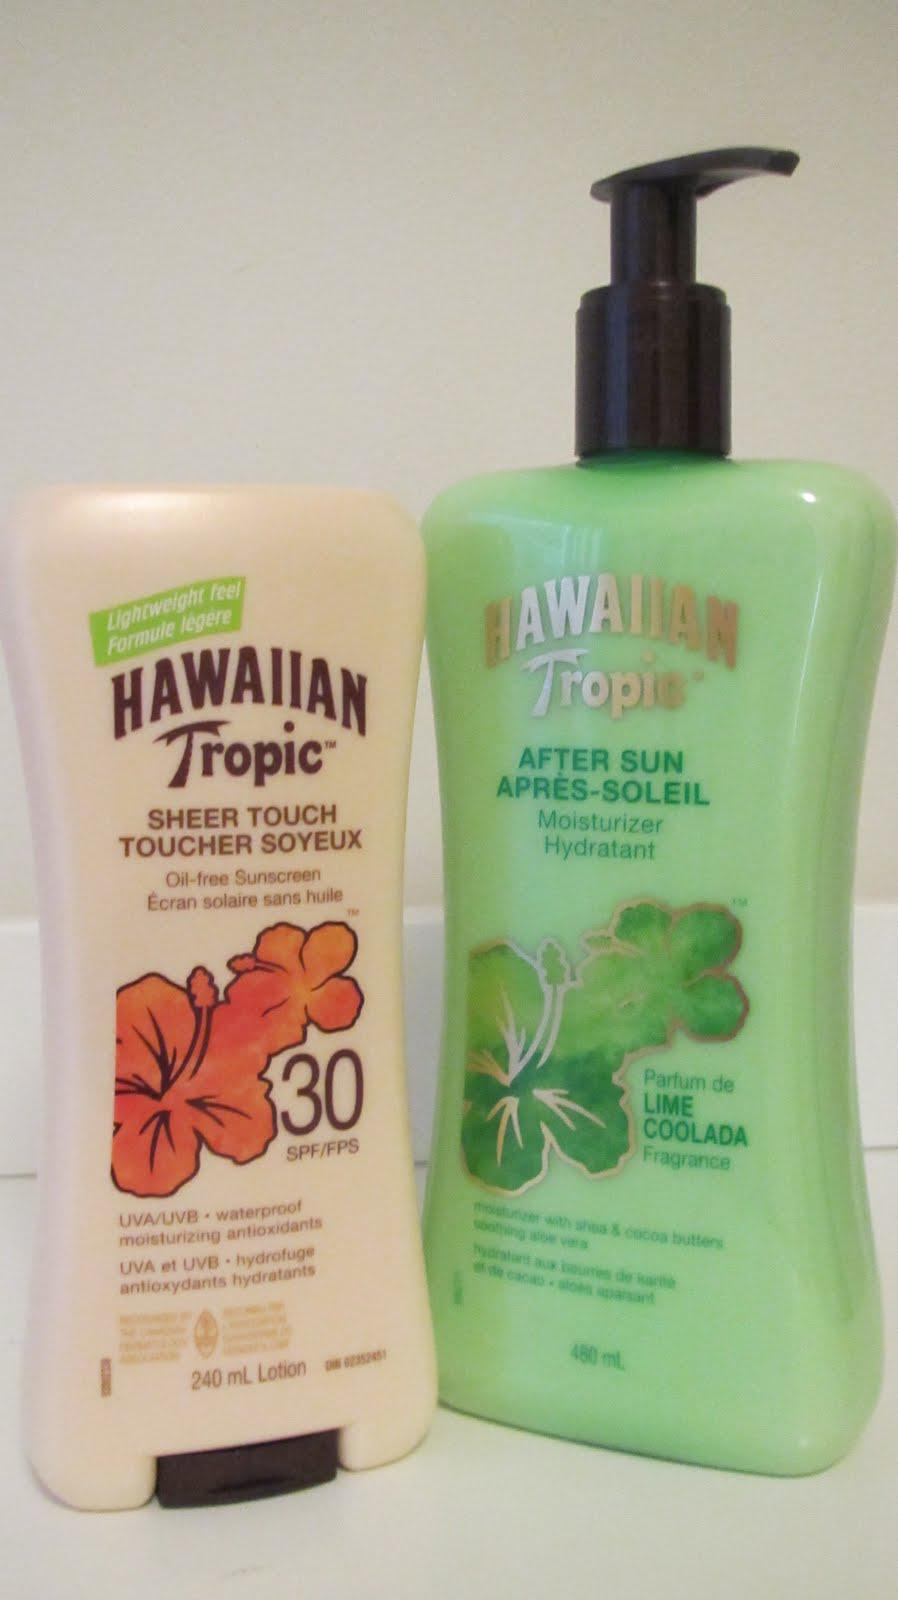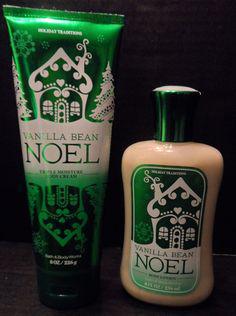The first image is the image on the left, the second image is the image on the right. For the images displayed, is the sentence "The left image shows exactly three products, each in a different packaging format." factually correct? Answer yes or no. No. The first image is the image on the left, the second image is the image on the right. Examine the images to the left and right. Is the description "A short wide pump bottle of lotion is shown with one other product in one image and with two other products in the other image." accurate? Answer yes or no. No. 